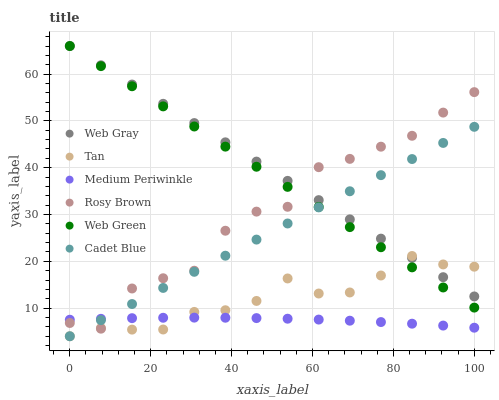Does Medium Periwinkle have the minimum area under the curve?
Answer yes or no. Yes. Does Web Gray have the maximum area under the curve?
Answer yes or no. Yes. Does Rosy Brown have the minimum area under the curve?
Answer yes or no. No. Does Rosy Brown have the maximum area under the curve?
Answer yes or no. No. Is Cadet Blue the smoothest?
Answer yes or no. Yes. Is Rosy Brown the roughest?
Answer yes or no. Yes. Is Medium Periwinkle the smoothest?
Answer yes or no. No. Is Medium Periwinkle the roughest?
Answer yes or no. No. Does Cadet Blue have the lowest value?
Answer yes or no. Yes. Does Rosy Brown have the lowest value?
Answer yes or no. No. Does Web Gray have the highest value?
Answer yes or no. Yes. Does Rosy Brown have the highest value?
Answer yes or no. No. Is Medium Periwinkle less than Web Gray?
Answer yes or no. Yes. Is Web Green greater than Medium Periwinkle?
Answer yes or no. Yes. Does Cadet Blue intersect Tan?
Answer yes or no. Yes. Is Cadet Blue less than Tan?
Answer yes or no. No. Is Cadet Blue greater than Tan?
Answer yes or no. No. Does Medium Periwinkle intersect Web Gray?
Answer yes or no. No. 